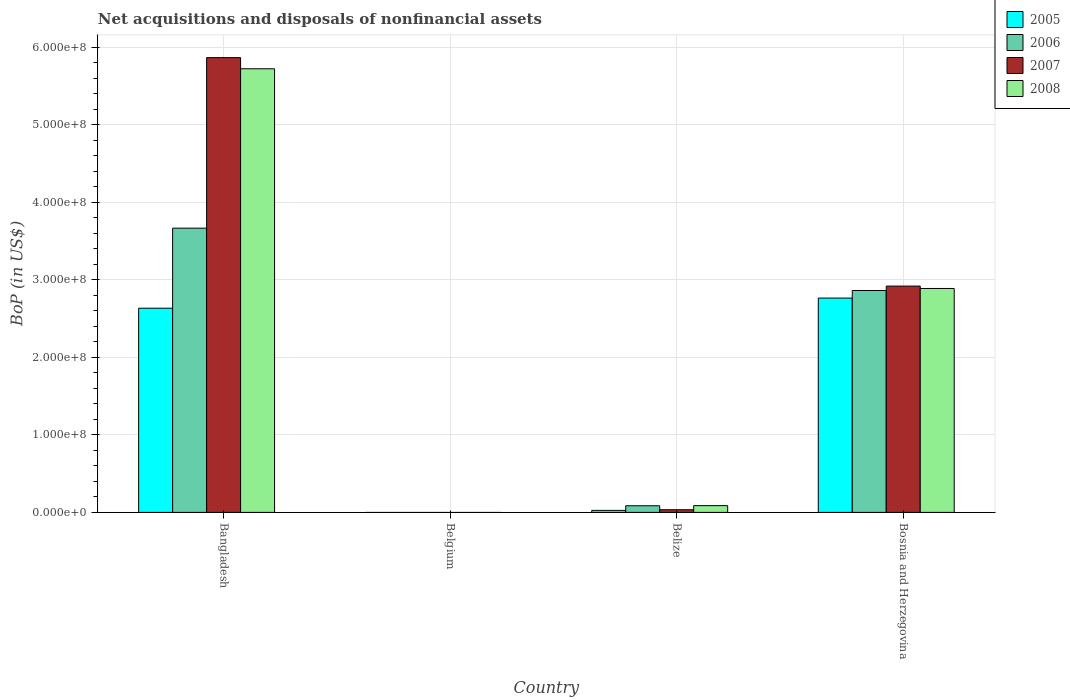How many different coloured bars are there?
Ensure brevity in your answer.  4. How many bars are there on the 2nd tick from the right?
Give a very brief answer. 4. In how many cases, is the number of bars for a given country not equal to the number of legend labels?
Provide a succinct answer. 1. What is the Balance of Payments in 2006 in Belize?
Keep it short and to the point. 8.57e+06. Across all countries, what is the maximum Balance of Payments in 2006?
Your response must be concise. 3.67e+08. In which country was the Balance of Payments in 2007 maximum?
Offer a very short reply. Bangladesh. What is the total Balance of Payments in 2006 in the graph?
Provide a succinct answer. 6.61e+08. What is the difference between the Balance of Payments in 2005 in Bangladesh and that in Belize?
Ensure brevity in your answer.  2.61e+08. What is the difference between the Balance of Payments in 2005 in Belize and the Balance of Payments in 2008 in Belgium?
Your answer should be compact. 2.59e+06. What is the average Balance of Payments in 2008 per country?
Keep it short and to the point. 2.17e+08. What is the difference between the Balance of Payments of/in 2007 and Balance of Payments of/in 2005 in Belize?
Give a very brief answer. 8.56e+05. What is the ratio of the Balance of Payments in 2006 in Bangladesh to that in Belize?
Make the answer very short. 42.8. Is the difference between the Balance of Payments in 2007 in Bangladesh and Bosnia and Herzegovina greater than the difference between the Balance of Payments in 2005 in Bangladesh and Bosnia and Herzegovina?
Your response must be concise. Yes. What is the difference between the highest and the second highest Balance of Payments in 2006?
Keep it short and to the point. -3.58e+08. What is the difference between the highest and the lowest Balance of Payments in 2007?
Offer a very short reply. 5.87e+08. In how many countries, is the Balance of Payments in 2005 greater than the average Balance of Payments in 2005 taken over all countries?
Offer a very short reply. 2. Is it the case that in every country, the sum of the Balance of Payments in 2008 and Balance of Payments in 2006 is greater than the Balance of Payments in 2007?
Make the answer very short. No. How many bars are there?
Provide a short and direct response. 12. Are all the bars in the graph horizontal?
Your answer should be very brief. No. Does the graph contain any zero values?
Offer a terse response. Yes. How are the legend labels stacked?
Your answer should be very brief. Vertical. What is the title of the graph?
Provide a short and direct response. Net acquisitions and disposals of nonfinancial assets. What is the label or title of the Y-axis?
Your answer should be compact. BoP (in US$). What is the BoP (in US$) in 2005 in Bangladesh?
Your answer should be compact. 2.63e+08. What is the BoP (in US$) in 2006 in Bangladesh?
Make the answer very short. 3.67e+08. What is the BoP (in US$) in 2007 in Bangladesh?
Offer a very short reply. 5.87e+08. What is the BoP (in US$) of 2008 in Bangladesh?
Provide a succinct answer. 5.72e+08. What is the BoP (in US$) of 2007 in Belgium?
Ensure brevity in your answer.  0. What is the BoP (in US$) in 2005 in Belize?
Make the answer very short. 2.59e+06. What is the BoP (in US$) of 2006 in Belize?
Offer a very short reply. 8.57e+06. What is the BoP (in US$) in 2007 in Belize?
Provide a succinct answer. 3.45e+06. What is the BoP (in US$) of 2008 in Belize?
Your response must be concise. 8.73e+06. What is the BoP (in US$) of 2005 in Bosnia and Herzegovina?
Give a very brief answer. 2.76e+08. What is the BoP (in US$) in 2006 in Bosnia and Herzegovina?
Ensure brevity in your answer.  2.86e+08. What is the BoP (in US$) in 2007 in Bosnia and Herzegovina?
Your answer should be compact. 2.92e+08. What is the BoP (in US$) of 2008 in Bosnia and Herzegovina?
Ensure brevity in your answer.  2.89e+08. Across all countries, what is the maximum BoP (in US$) in 2005?
Your answer should be very brief. 2.76e+08. Across all countries, what is the maximum BoP (in US$) of 2006?
Your answer should be very brief. 3.67e+08. Across all countries, what is the maximum BoP (in US$) of 2007?
Ensure brevity in your answer.  5.87e+08. Across all countries, what is the maximum BoP (in US$) of 2008?
Offer a terse response. 5.72e+08. Across all countries, what is the minimum BoP (in US$) in 2007?
Make the answer very short. 0. What is the total BoP (in US$) of 2005 in the graph?
Offer a very short reply. 5.42e+08. What is the total BoP (in US$) of 2006 in the graph?
Your response must be concise. 6.61e+08. What is the total BoP (in US$) in 2007 in the graph?
Ensure brevity in your answer.  8.82e+08. What is the total BoP (in US$) of 2008 in the graph?
Your response must be concise. 8.70e+08. What is the difference between the BoP (in US$) in 2005 in Bangladesh and that in Belize?
Offer a terse response. 2.61e+08. What is the difference between the BoP (in US$) in 2006 in Bangladesh and that in Belize?
Give a very brief answer. 3.58e+08. What is the difference between the BoP (in US$) in 2007 in Bangladesh and that in Belize?
Provide a short and direct response. 5.83e+08. What is the difference between the BoP (in US$) in 2008 in Bangladesh and that in Belize?
Make the answer very short. 5.63e+08. What is the difference between the BoP (in US$) in 2005 in Bangladesh and that in Bosnia and Herzegovina?
Offer a very short reply. -1.31e+07. What is the difference between the BoP (in US$) in 2006 in Bangladesh and that in Bosnia and Herzegovina?
Offer a terse response. 8.04e+07. What is the difference between the BoP (in US$) in 2007 in Bangladesh and that in Bosnia and Herzegovina?
Offer a terse response. 2.95e+08. What is the difference between the BoP (in US$) of 2008 in Bangladesh and that in Bosnia and Herzegovina?
Ensure brevity in your answer.  2.83e+08. What is the difference between the BoP (in US$) of 2005 in Belize and that in Bosnia and Herzegovina?
Keep it short and to the point. -2.74e+08. What is the difference between the BoP (in US$) of 2006 in Belize and that in Bosnia and Herzegovina?
Keep it short and to the point. -2.78e+08. What is the difference between the BoP (in US$) in 2007 in Belize and that in Bosnia and Herzegovina?
Your response must be concise. -2.88e+08. What is the difference between the BoP (in US$) of 2008 in Belize and that in Bosnia and Herzegovina?
Your answer should be compact. -2.80e+08. What is the difference between the BoP (in US$) of 2005 in Bangladesh and the BoP (in US$) of 2006 in Belize?
Your response must be concise. 2.55e+08. What is the difference between the BoP (in US$) in 2005 in Bangladesh and the BoP (in US$) in 2007 in Belize?
Your answer should be very brief. 2.60e+08. What is the difference between the BoP (in US$) in 2005 in Bangladesh and the BoP (in US$) in 2008 in Belize?
Offer a terse response. 2.55e+08. What is the difference between the BoP (in US$) of 2006 in Bangladesh and the BoP (in US$) of 2007 in Belize?
Ensure brevity in your answer.  3.63e+08. What is the difference between the BoP (in US$) in 2006 in Bangladesh and the BoP (in US$) in 2008 in Belize?
Offer a terse response. 3.58e+08. What is the difference between the BoP (in US$) in 2007 in Bangladesh and the BoP (in US$) in 2008 in Belize?
Your response must be concise. 5.78e+08. What is the difference between the BoP (in US$) of 2005 in Bangladesh and the BoP (in US$) of 2006 in Bosnia and Herzegovina?
Your answer should be very brief. -2.29e+07. What is the difference between the BoP (in US$) in 2005 in Bangladesh and the BoP (in US$) in 2007 in Bosnia and Herzegovina?
Keep it short and to the point. -2.85e+07. What is the difference between the BoP (in US$) in 2005 in Bangladesh and the BoP (in US$) in 2008 in Bosnia and Herzegovina?
Keep it short and to the point. -2.55e+07. What is the difference between the BoP (in US$) of 2006 in Bangladesh and the BoP (in US$) of 2007 in Bosnia and Herzegovina?
Ensure brevity in your answer.  7.47e+07. What is the difference between the BoP (in US$) of 2006 in Bangladesh and the BoP (in US$) of 2008 in Bosnia and Herzegovina?
Give a very brief answer. 7.78e+07. What is the difference between the BoP (in US$) in 2007 in Bangladesh and the BoP (in US$) in 2008 in Bosnia and Herzegovina?
Provide a short and direct response. 2.98e+08. What is the difference between the BoP (in US$) of 2005 in Belize and the BoP (in US$) of 2006 in Bosnia and Herzegovina?
Your answer should be compact. -2.84e+08. What is the difference between the BoP (in US$) of 2005 in Belize and the BoP (in US$) of 2007 in Bosnia and Herzegovina?
Give a very brief answer. -2.89e+08. What is the difference between the BoP (in US$) in 2005 in Belize and the BoP (in US$) in 2008 in Bosnia and Herzegovina?
Your answer should be compact. -2.86e+08. What is the difference between the BoP (in US$) in 2006 in Belize and the BoP (in US$) in 2007 in Bosnia and Herzegovina?
Keep it short and to the point. -2.83e+08. What is the difference between the BoP (in US$) of 2006 in Belize and the BoP (in US$) of 2008 in Bosnia and Herzegovina?
Your response must be concise. -2.80e+08. What is the difference between the BoP (in US$) in 2007 in Belize and the BoP (in US$) in 2008 in Bosnia and Herzegovina?
Make the answer very short. -2.85e+08. What is the average BoP (in US$) in 2005 per country?
Provide a succinct answer. 1.36e+08. What is the average BoP (in US$) of 2006 per country?
Give a very brief answer. 1.65e+08. What is the average BoP (in US$) in 2007 per country?
Your answer should be very brief. 2.20e+08. What is the average BoP (in US$) in 2008 per country?
Make the answer very short. 2.17e+08. What is the difference between the BoP (in US$) of 2005 and BoP (in US$) of 2006 in Bangladesh?
Offer a very short reply. -1.03e+08. What is the difference between the BoP (in US$) of 2005 and BoP (in US$) of 2007 in Bangladesh?
Give a very brief answer. -3.23e+08. What is the difference between the BoP (in US$) of 2005 and BoP (in US$) of 2008 in Bangladesh?
Your answer should be very brief. -3.09e+08. What is the difference between the BoP (in US$) in 2006 and BoP (in US$) in 2007 in Bangladesh?
Keep it short and to the point. -2.20e+08. What is the difference between the BoP (in US$) in 2006 and BoP (in US$) in 2008 in Bangladesh?
Make the answer very short. -2.06e+08. What is the difference between the BoP (in US$) in 2007 and BoP (in US$) in 2008 in Bangladesh?
Ensure brevity in your answer.  1.44e+07. What is the difference between the BoP (in US$) of 2005 and BoP (in US$) of 2006 in Belize?
Ensure brevity in your answer.  -5.98e+06. What is the difference between the BoP (in US$) of 2005 and BoP (in US$) of 2007 in Belize?
Ensure brevity in your answer.  -8.56e+05. What is the difference between the BoP (in US$) of 2005 and BoP (in US$) of 2008 in Belize?
Your answer should be compact. -6.14e+06. What is the difference between the BoP (in US$) in 2006 and BoP (in US$) in 2007 in Belize?
Offer a very short reply. 5.12e+06. What is the difference between the BoP (in US$) of 2006 and BoP (in US$) of 2008 in Belize?
Your answer should be compact. -1.61e+05. What is the difference between the BoP (in US$) of 2007 and BoP (in US$) of 2008 in Belize?
Make the answer very short. -5.28e+06. What is the difference between the BoP (in US$) of 2005 and BoP (in US$) of 2006 in Bosnia and Herzegovina?
Your answer should be compact. -9.77e+06. What is the difference between the BoP (in US$) in 2005 and BoP (in US$) in 2007 in Bosnia and Herzegovina?
Offer a very short reply. -1.54e+07. What is the difference between the BoP (in US$) of 2005 and BoP (in US$) of 2008 in Bosnia and Herzegovina?
Ensure brevity in your answer.  -1.24e+07. What is the difference between the BoP (in US$) of 2006 and BoP (in US$) of 2007 in Bosnia and Herzegovina?
Make the answer very short. -5.67e+06. What is the difference between the BoP (in US$) of 2006 and BoP (in US$) of 2008 in Bosnia and Herzegovina?
Keep it short and to the point. -2.60e+06. What is the difference between the BoP (in US$) of 2007 and BoP (in US$) of 2008 in Bosnia and Herzegovina?
Provide a succinct answer. 3.07e+06. What is the ratio of the BoP (in US$) of 2005 in Bangladesh to that in Belize?
Make the answer very short. 101.69. What is the ratio of the BoP (in US$) of 2006 in Bangladesh to that in Belize?
Your answer should be very brief. 42.8. What is the ratio of the BoP (in US$) in 2007 in Bangladesh to that in Belize?
Offer a terse response. 170.21. What is the ratio of the BoP (in US$) in 2008 in Bangladesh to that in Belize?
Give a very brief answer. 65.57. What is the ratio of the BoP (in US$) in 2005 in Bangladesh to that in Bosnia and Herzegovina?
Make the answer very short. 0.95. What is the ratio of the BoP (in US$) in 2006 in Bangladesh to that in Bosnia and Herzegovina?
Make the answer very short. 1.28. What is the ratio of the BoP (in US$) in 2007 in Bangladesh to that in Bosnia and Herzegovina?
Make the answer very short. 2.01. What is the ratio of the BoP (in US$) of 2008 in Bangladesh to that in Bosnia and Herzegovina?
Offer a very short reply. 1.98. What is the ratio of the BoP (in US$) in 2005 in Belize to that in Bosnia and Herzegovina?
Provide a succinct answer. 0.01. What is the ratio of the BoP (in US$) in 2006 in Belize to that in Bosnia and Herzegovina?
Keep it short and to the point. 0.03. What is the ratio of the BoP (in US$) in 2007 in Belize to that in Bosnia and Herzegovina?
Provide a succinct answer. 0.01. What is the ratio of the BoP (in US$) of 2008 in Belize to that in Bosnia and Herzegovina?
Give a very brief answer. 0.03. What is the difference between the highest and the second highest BoP (in US$) in 2005?
Your response must be concise. 1.31e+07. What is the difference between the highest and the second highest BoP (in US$) in 2006?
Your response must be concise. 8.04e+07. What is the difference between the highest and the second highest BoP (in US$) of 2007?
Your response must be concise. 2.95e+08. What is the difference between the highest and the second highest BoP (in US$) of 2008?
Provide a succinct answer. 2.83e+08. What is the difference between the highest and the lowest BoP (in US$) in 2005?
Provide a succinct answer. 2.76e+08. What is the difference between the highest and the lowest BoP (in US$) of 2006?
Offer a very short reply. 3.67e+08. What is the difference between the highest and the lowest BoP (in US$) of 2007?
Your answer should be compact. 5.87e+08. What is the difference between the highest and the lowest BoP (in US$) of 2008?
Keep it short and to the point. 5.72e+08. 